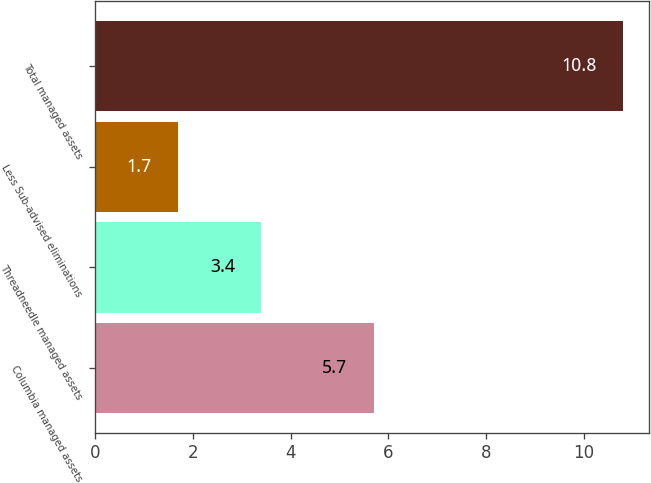Convert chart to OTSL. <chart><loc_0><loc_0><loc_500><loc_500><bar_chart><fcel>Columbia managed assets<fcel>Threadneedle managed assets<fcel>Less Sub-advised eliminations<fcel>Total managed assets<nl><fcel>5.7<fcel>3.4<fcel>1.7<fcel>10.8<nl></chart> 